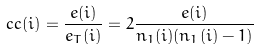<formula> <loc_0><loc_0><loc_500><loc_500>c c ( i ) = \frac { e ( i ) } { e _ { T } ( i ) } = 2 \frac { e ( i ) } { n _ { 1 } ( i ) ( n _ { 1 } ( i ) - 1 ) }</formula> 